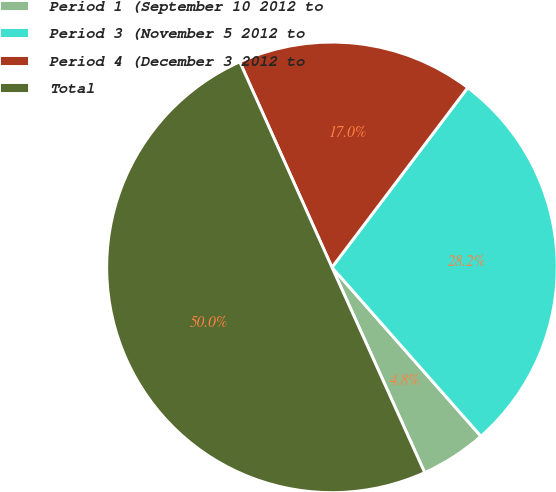Convert chart. <chart><loc_0><loc_0><loc_500><loc_500><pie_chart><fcel>Period 1 (September 10 2012 to<fcel>Period 3 (November 5 2012 to<fcel>Period 4 (December 3 2012 to<fcel>Total<nl><fcel>4.75%<fcel>28.2%<fcel>17.01%<fcel>50.04%<nl></chart> 